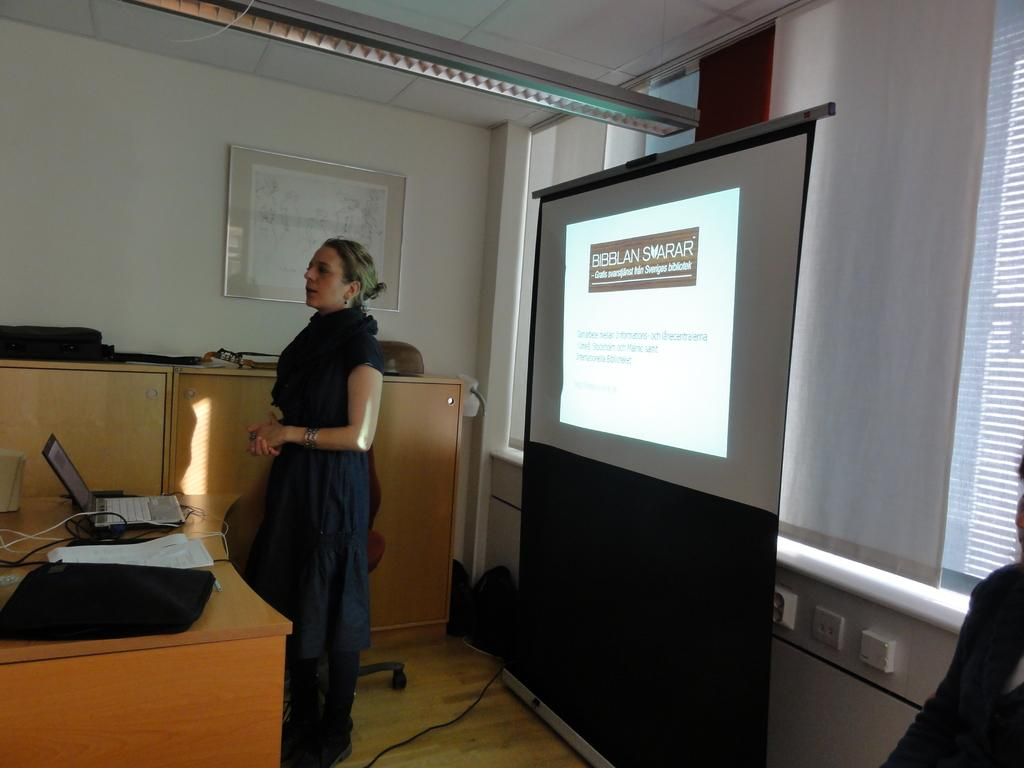What is the main subject of the image? There is a woman standing in the image. What object can be seen on a table in the image? There is a laptop on a table in the image. What type of screen is visible in the image? There is a projector screen visible in the image. How many tomatoes are on the projector screen in the image? There are no tomatoes present on the projector screen in the image. What type of love is being expressed by the woman in the image? There is no indication of love or any emotion being expressed by the woman in the image. 